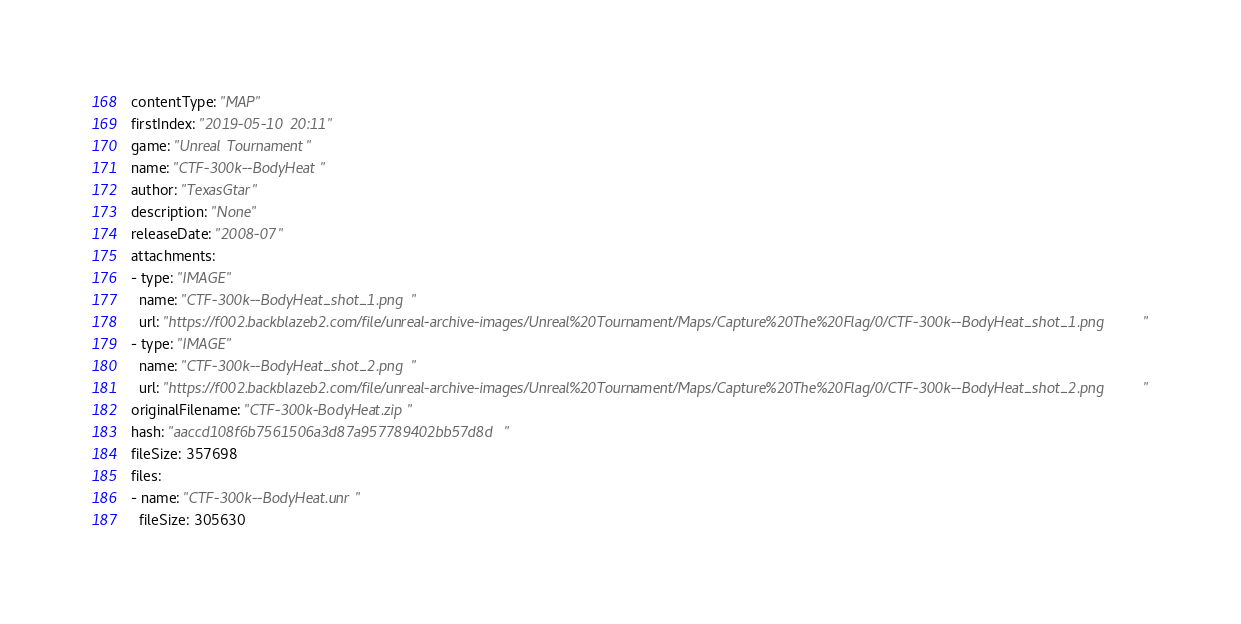<code> <loc_0><loc_0><loc_500><loc_500><_YAML_>contentType: "MAP"
firstIndex: "2019-05-10 20:11"
game: "Unreal Tournament"
name: "CTF-300k--BodyHeat"
author: "TexasGtar"
description: "None"
releaseDate: "2008-07"
attachments:
- type: "IMAGE"
  name: "CTF-300k--BodyHeat_shot_1.png"
  url: "https://f002.backblazeb2.com/file/unreal-archive-images/Unreal%20Tournament/Maps/Capture%20The%20Flag/0/CTF-300k--BodyHeat_shot_1.png"
- type: "IMAGE"
  name: "CTF-300k--BodyHeat_shot_2.png"
  url: "https://f002.backblazeb2.com/file/unreal-archive-images/Unreal%20Tournament/Maps/Capture%20The%20Flag/0/CTF-300k--BodyHeat_shot_2.png"
originalFilename: "CTF-300k-BodyHeat.zip"
hash: "aaccd108f6b7561506a3d87a957789402bb57d8d"
fileSize: 357698
files:
- name: "CTF-300k--BodyHeat.unr"
  fileSize: 305630</code> 